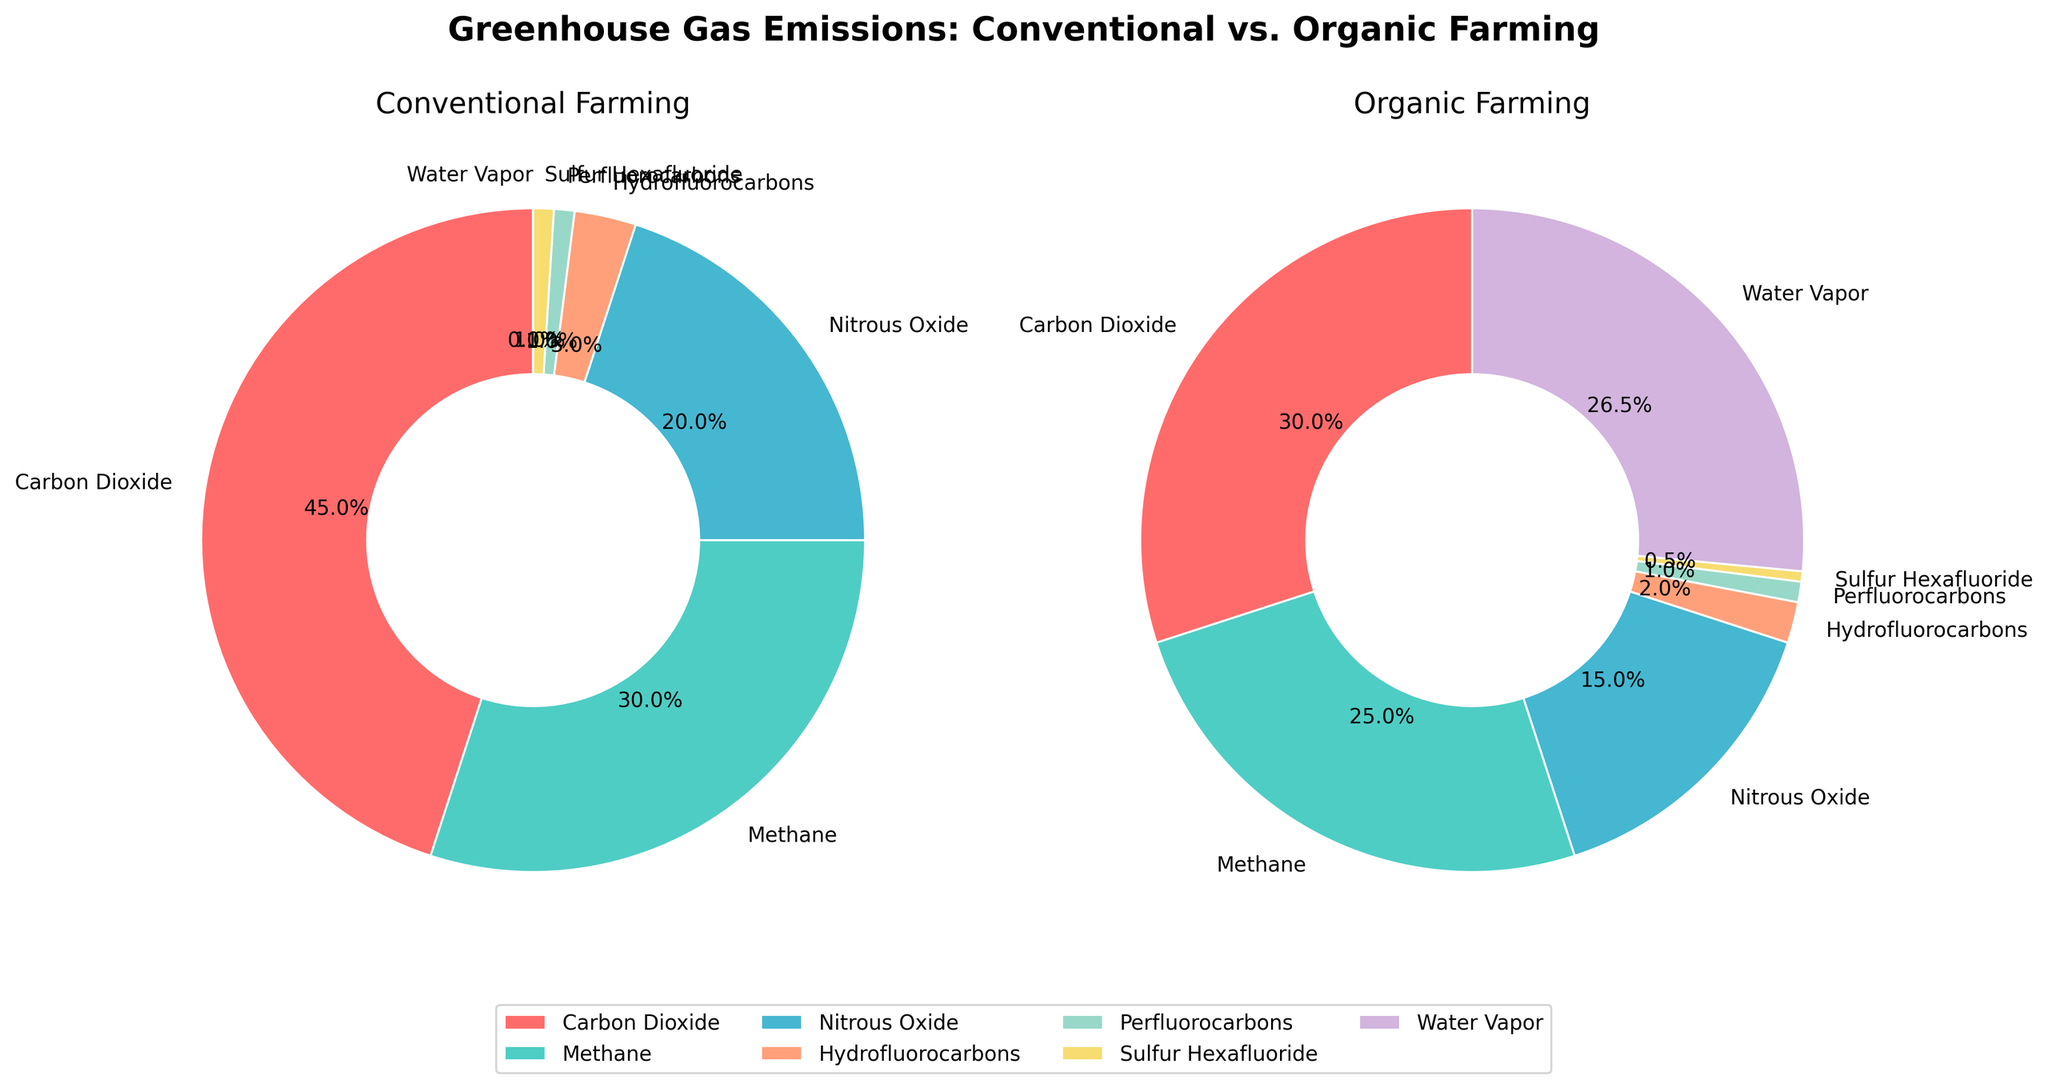What percentage of greenhouse gas emissions is due to Carbon Dioxide in both farming methods? To find this, we look at the pie chart sections labeled "Carbon Dioxide" in both Conventional and Organic Farming plots. The Conventional Farming chart shows 45%, while the Organic Farming chart shows 30%.
Answer: Conventional: 45%, Organic: 30% Which greenhouse gas shows the most significant difference in emissions between Conventional and Organic farming? To determine this, compare the emission percentages of each greenhouse gas between the two farming methods. Carbon Dioxide has a 15% difference (45% in Conventional vs. 30% in Organic), which is the highest difference among all gases listed.
Answer: Carbon Dioxide How much higher are the Methane emissions in Conventional farming compared to Organic farming? Look at the Methane percentage in both pie charts. Conventional Farming has 30%, while Organic Farming has 25%. The difference is calculated as 30% - 25% = 5%.
Answer: 5% What is the total percentage of Carbon Dioxide and Methane emissions in Organic farming? Simply sum the Carbon Dioxide (30%) and Methane (25%) emissions from the Organic Farming chart. 30% + 25% = 55%.
Answer: 55% What is the median percentage of greenhouse gas emissions in Organic farming? List the percentages for Organic farming in ascending order: 0.5%, 1%, 2%, 15%, 25%, 26.5%, 30%. The median value is the middle number, which is 15%.
Answer: 15% Which farm method has a higher percentage of Water Vapor emissions, and by how much? Check the Water Vapor emissions in both charts. Organic Farming has 26.5%, while Conventional Farming has 0%. The difference is 26.5%. Therefore, Organic farming has higher emissions by 26.5%.
Answer: Organic, 26.5% In Conventional farming, how much do the Nitrous Oxide and Sulfur Hexafluoride emissions contribute together to overall greenhouse gas emissions? Sum the percentages of Nitrous Oxide (20%) and Sulfur Hexafluoride (1%) from the Conventional Farming chart. 20% + 1% = 21%.
Answer: 21% Which greenhouse gas contributes the least to overall emissions in Organic farming? Identify the greenhouse gas with the smallest percentage in the Organic Farming chart, which is Sulfur Hexafluoride at 0.5%.
Answer: Sulfur Hexafluoride 